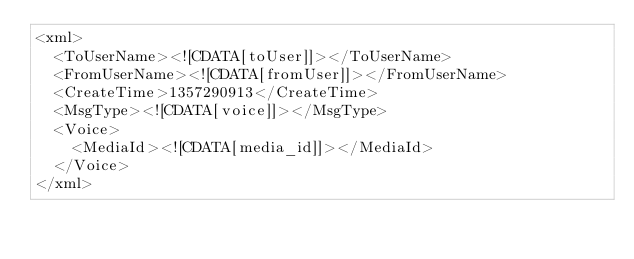Convert code to text. <code><loc_0><loc_0><loc_500><loc_500><_XML_><xml>
  <ToUserName><![CDATA[toUser]]></ToUserName>
  <FromUserName><![CDATA[fromUser]]></FromUserName>
  <CreateTime>1357290913</CreateTime>
  <MsgType><![CDATA[voice]]></MsgType>
  <Voice>
    <MediaId><![CDATA[media_id]]></MediaId>
  </Voice>
</xml>
</code> 